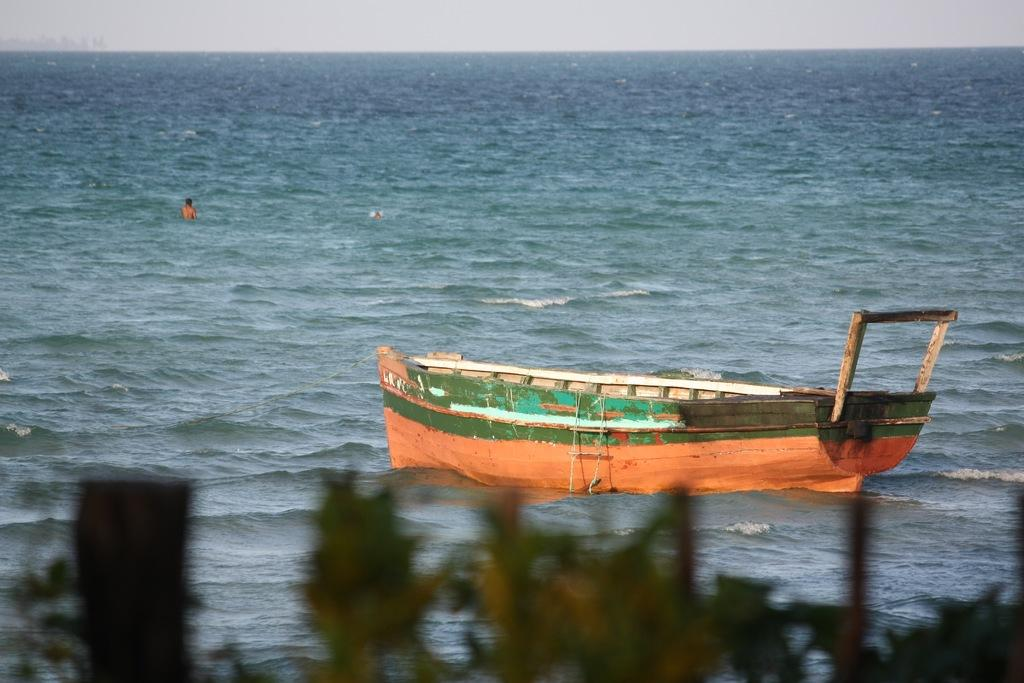What is the main subject of the image? The main subject of the image is a boat. Where is the boat located? The boat is on the water. Is there anyone near the boat? Yes, there is a person in the water. What else can be seen in the image besides the boat and person? There are plants visible in the image. What is visible at the top of the image? The sky is visible at the top of the image. Can you see an airplane flying over the lake in the image? There is no lake or airplane present in the image; it features a boat on the water with a person and plants visible. What type of shoe is the person wearing while swimming in the image? There is no shoe visible in the image, as the person is in the water without any footwear. 